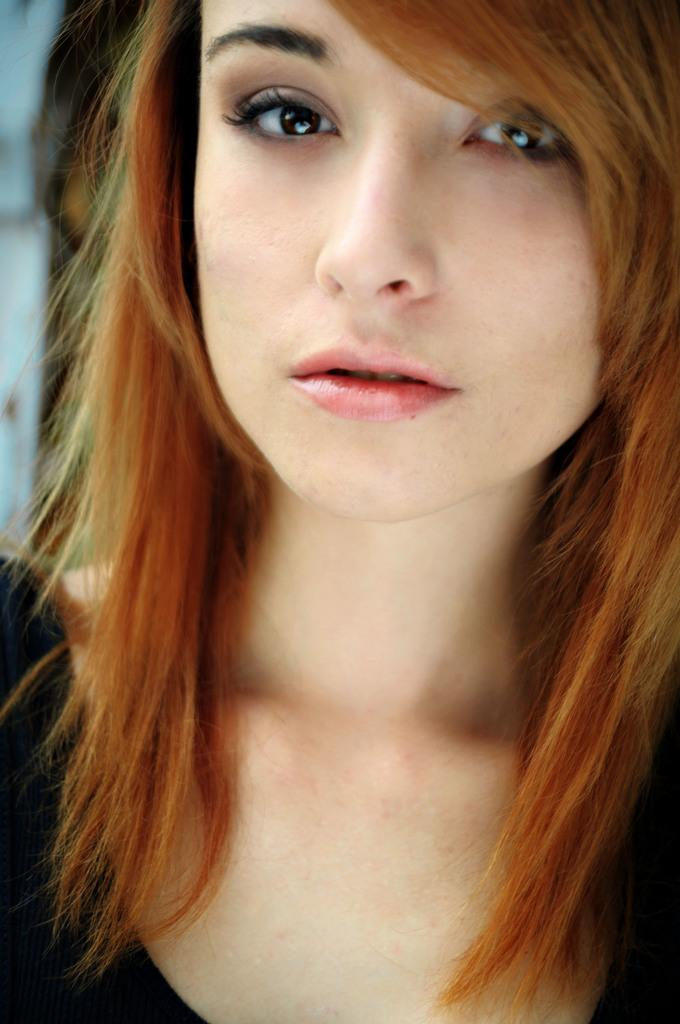Who is present in the image? There is a woman in the image. What is the woman wearing? The woman is wearing a black dress. What type of crate is visible in the image? There is no crate present in the image. Is the woman standing on grass in the image? The provided facts do not mention any grass in the image, so we cannot determine if the woman is standing on grass. 